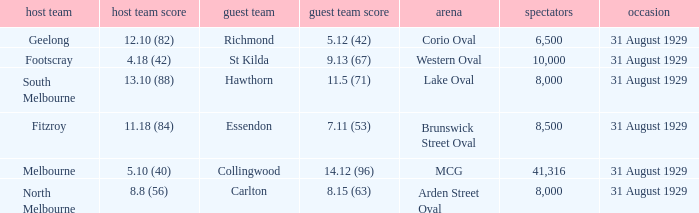What was the score of the home team when the away team scored 14.12 (96)? 5.10 (40). 